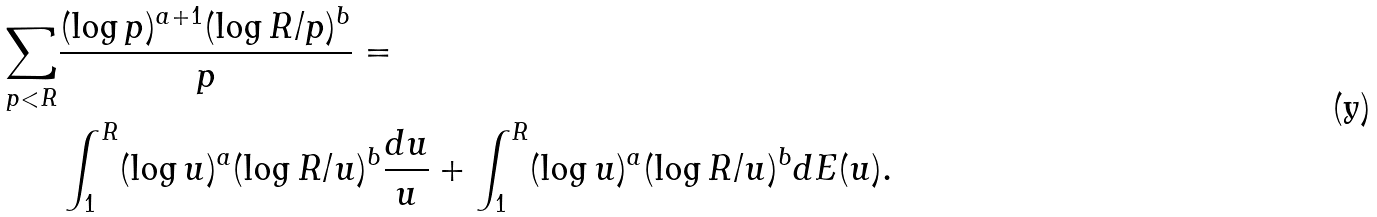Convert formula to latex. <formula><loc_0><loc_0><loc_500><loc_500>\sum _ { p < R } & \frac { ( \log p ) ^ { a + 1 } ( \log R / p ) ^ { b } } { p } = \\ & \int _ { 1 } ^ { R } ( \log u ) ^ { a } ( \log R / u ) ^ { b } \frac { d u } { u } + \int _ { 1 } ^ { R } ( \log u ) ^ { a } ( \log R / u ) ^ { b } d E ( u ) .</formula> 